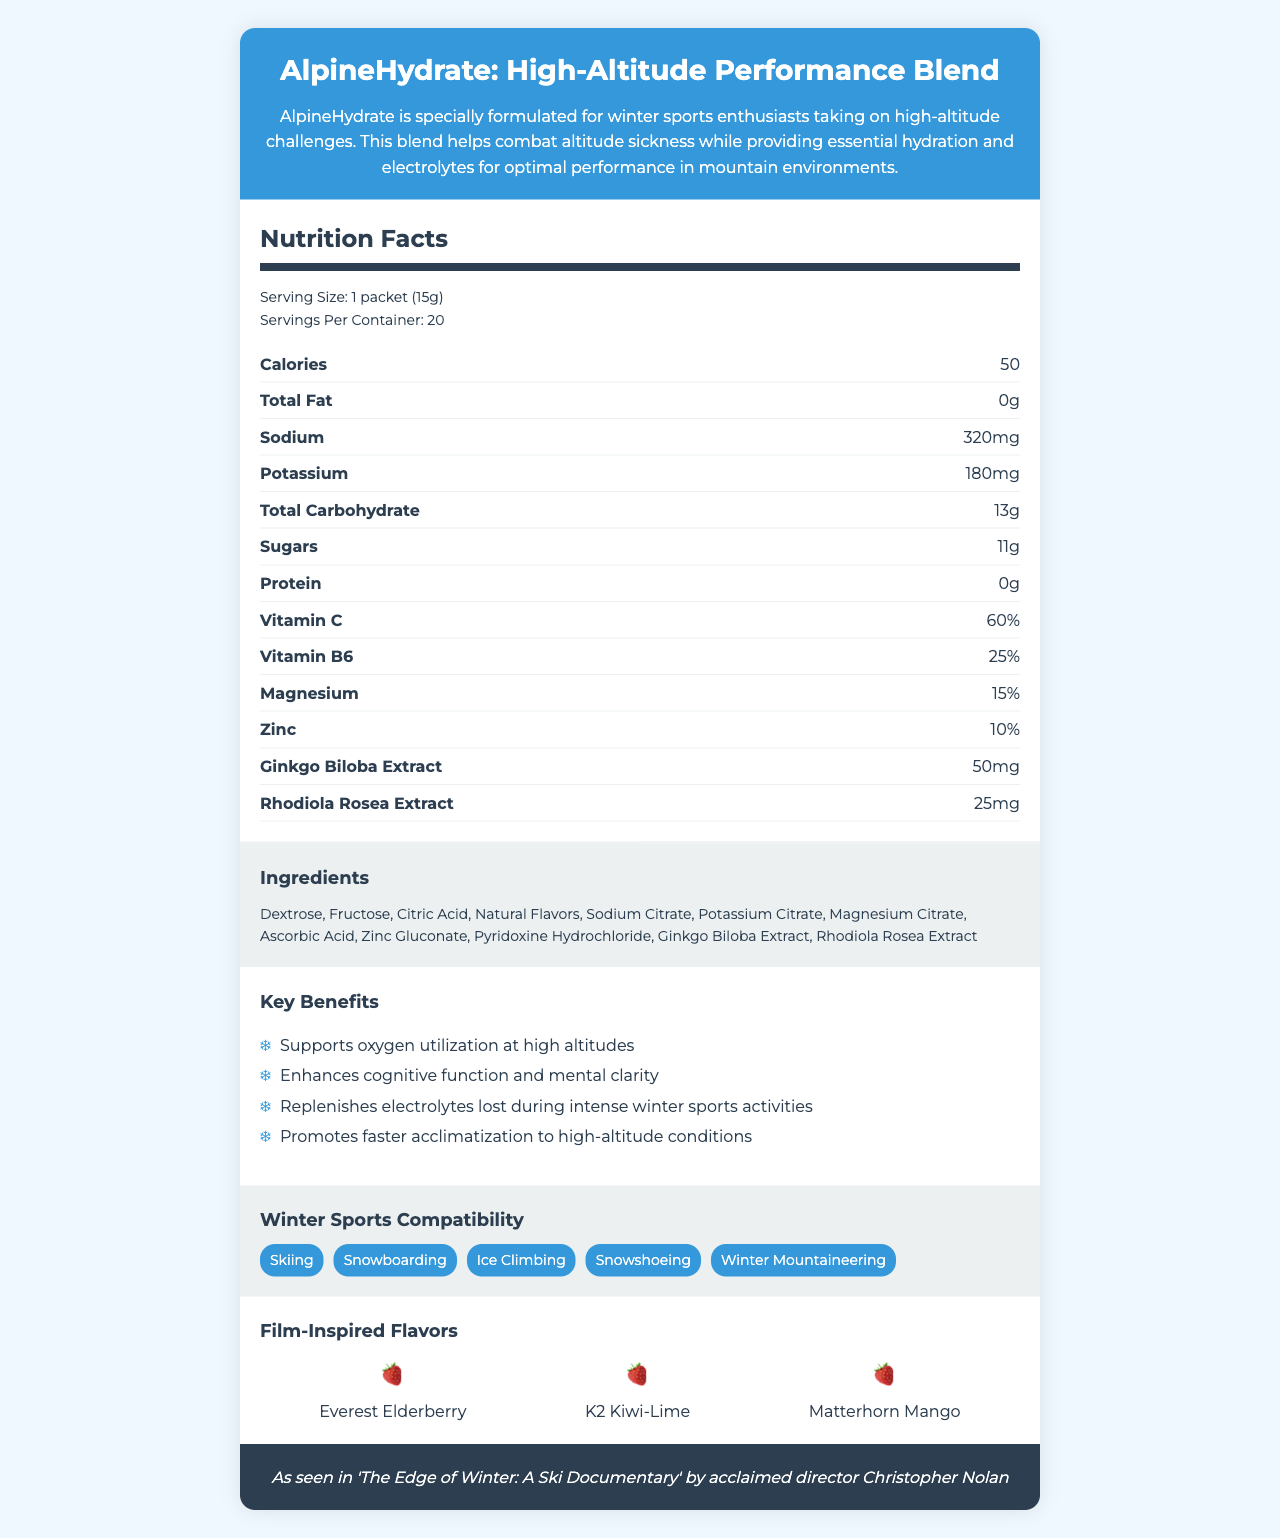what is the product name? The product name is given at the beginning of the document under the title.
Answer: AlpineHydrate: High-Altitude Performance Blend what is the serving size of the drink mix? The serving size is listed under the header "Nutrition Facts."
Answer: 1 packet (15g) how many servings are there in a container? The number of servings per container is mentioned under the "Nutrition Facts" section.
Answer: 20 how much sodium does one serving contain? The sodium content per serving is listed in the "Nutrition Facts" section.
Answer: 320mg what are the primary benefits of this hydration drink mix? The key benefits are listed under the "Key Benefits" section.
Answer: Supports oxygen utilization at high altitudes, Enhances cognitive function and mental clarity, Replenishes electrolytes, Promotes faster acclimatization which of the following is a film-inspired flavor? A. Everest Elderberry B. Himalayan Raspberry C. Alpine Apple The film-inspired flavors listed are Everest Elderberry, K2 Kiwi-Lime, and Matterhorn Mango. Himalayan Raspberry and Alpine Apple are not listed.
Answer: A what is the recommended way to consume AlpineHydrate? This information is given in the "Directions" section of the document.
Answer: Mix one packet with 16-20 oz of water. Consume 1-2 servings per day during high-altitude activities is this product produced in a facility that processes milk? The allergen information states that the product is produced in a facility that also processes milk, soy, and tree nuts.
Answer: Yes which winter sport is this product compatible with? A. Snowboarding B. Surfing C. Cycling D. Marathon Running The compatible winter sports listed are Skiing, Snowboarding, Ice Climbing, Snowshoeing, and Winter Mountaineering. Surfing, Cycling, and Marathon Running are not listed.
Answer: A does the product contain any fat? The "Total Fat" content listed in the "Nutrition Facts" section is 0g.
Answer: No summarize the document. The document provides detailed information about the product name, purpose, nutritional content, benefits, compatibility with winter sports, ingredients, and film-inspired flavors.
Answer: AlpineHydrate: High-Altitude Performance Blend is a hydration drink mix formulated for winter sports enthusiasts to combat altitude sickness. It provides essential electrolytes, supports oxygen utilization, and enhances cognitive function. It is suitable for various winter sports and comes in flavors inspired by films. The serving size is 1 packet (15g), and each container has 20 servings, containing 50 calories and 320mg of sodium per serving. what is the protein content per serving in AlpineHydrate? The protein content per serving is listed as 0g in the "Nutrition Facts" section.
Answer: 0g what percentage of daily Vitamin C does one serving provide? The percentage of daily Vitamin C provided per serving is listed in the "Nutrition Facts" section.
Answer: 60% what are the main ingredients in AlpineHydrate? The ingredients are listed under the "Ingredients" section.
Answer: Dextrose, Fructose, Citric Acid, Natural Flavors, Sodium Citrate, Potassium Citrate, Magnesium Citrate, Ascorbic Acid, Zinc Gluconate, Pyridoxine Hydrochloride, Ginkgo Biloba Extract, Rhodiola Rosea Extract is the product endorsed by a film? The product is endorsed as seen in 'The Edge of Winter: A Ski Documentary' by acclaimed director Christopher Nolan.
Answer: Yes is this product suitable for summer sports? The document only mentions compatibility with winter sports such as skiing, snowboarding, ice climbing, snowshoeing, and winter mountaineering. There is no information about its suitability for summer sports.
Answer: Cannot be determined 